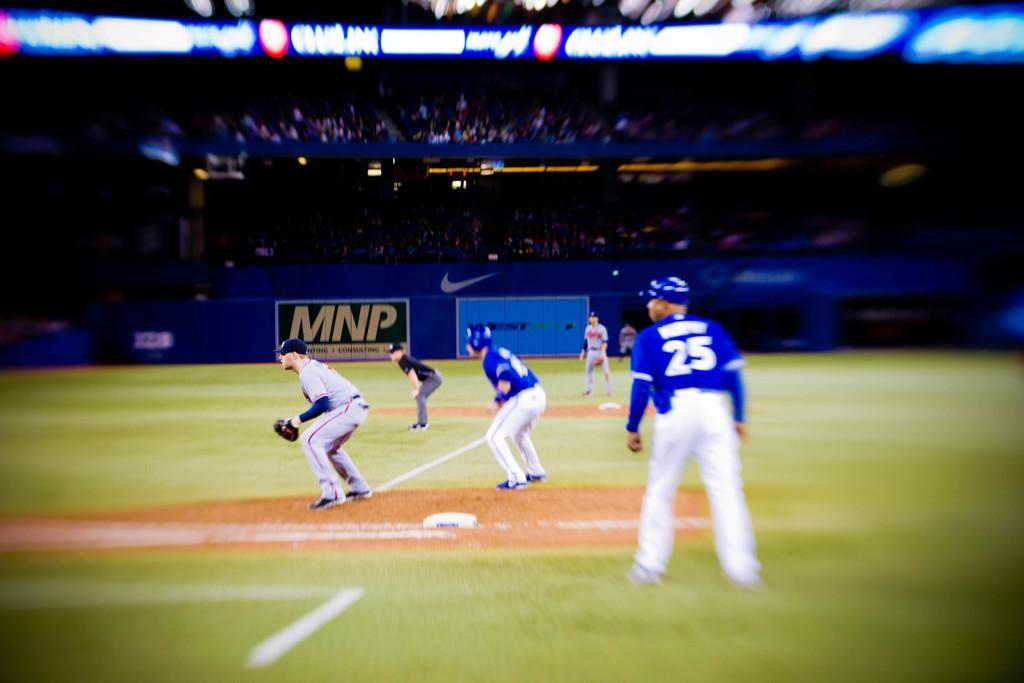<image>
Give a short and clear explanation of the subsequent image. Number 25 on the Blue team watches the play intently. 